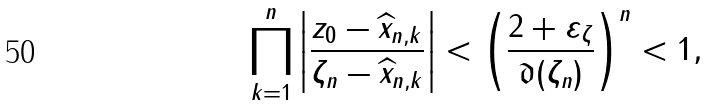Convert formula to latex. <formula><loc_0><loc_0><loc_500><loc_500>\prod _ { k = 1 } ^ { n } \left | \frac { z _ { 0 } - \widehat { x } _ { n , k } } { \zeta _ { n } - \widehat { x } _ { n , k } } \right | < \left ( \frac { 2 + \varepsilon _ { \zeta } } { \mathfrak { d } ( \zeta _ { n } ) } \right ) ^ { n } < 1 ,</formula> 